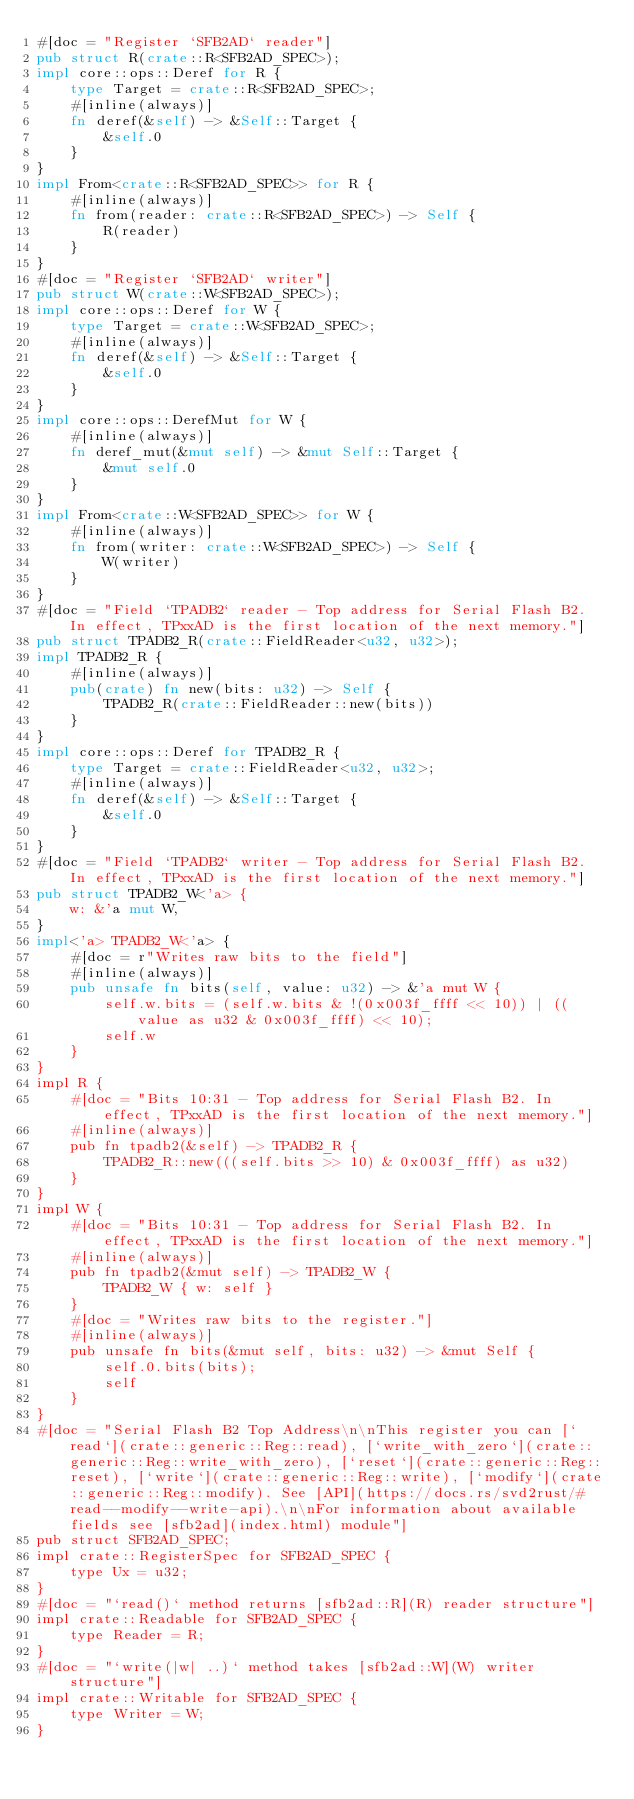<code> <loc_0><loc_0><loc_500><loc_500><_Rust_>#[doc = "Register `SFB2AD` reader"]
pub struct R(crate::R<SFB2AD_SPEC>);
impl core::ops::Deref for R {
    type Target = crate::R<SFB2AD_SPEC>;
    #[inline(always)]
    fn deref(&self) -> &Self::Target {
        &self.0
    }
}
impl From<crate::R<SFB2AD_SPEC>> for R {
    #[inline(always)]
    fn from(reader: crate::R<SFB2AD_SPEC>) -> Self {
        R(reader)
    }
}
#[doc = "Register `SFB2AD` writer"]
pub struct W(crate::W<SFB2AD_SPEC>);
impl core::ops::Deref for W {
    type Target = crate::W<SFB2AD_SPEC>;
    #[inline(always)]
    fn deref(&self) -> &Self::Target {
        &self.0
    }
}
impl core::ops::DerefMut for W {
    #[inline(always)]
    fn deref_mut(&mut self) -> &mut Self::Target {
        &mut self.0
    }
}
impl From<crate::W<SFB2AD_SPEC>> for W {
    #[inline(always)]
    fn from(writer: crate::W<SFB2AD_SPEC>) -> Self {
        W(writer)
    }
}
#[doc = "Field `TPADB2` reader - Top address for Serial Flash B2. In effect, TPxxAD is the first location of the next memory."]
pub struct TPADB2_R(crate::FieldReader<u32, u32>);
impl TPADB2_R {
    #[inline(always)]
    pub(crate) fn new(bits: u32) -> Self {
        TPADB2_R(crate::FieldReader::new(bits))
    }
}
impl core::ops::Deref for TPADB2_R {
    type Target = crate::FieldReader<u32, u32>;
    #[inline(always)]
    fn deref(&self) -> &Self::Target {
        &self.0
    }
}
#[doc = "Field `TPADB2` writer - Top address for Serial Flash B2. In effect, TPxxAD is the first location of the next memory."]
pub struct TPADB2_W<'a> {
    w: &'a mut W,
}
impl<'a> TPADB2_W<'a> {
    #[doc = r"Writes raw bits to the field"]
    #[inline(always)]
    pub unsafe fn bits(self, value: u32) -> &'a mut W {
        self.w.bits = (self.w.bits & !(0x003f_ffff << 10)) | ((value as u32 & 0x003f_ffff) << 10);
        self.w
    }
}
impl R {
    #[doc = "Bits 10:31 - Top address for Serial Flash B2. In effect, TPxxAD is the first location of the next memory."]
    #[inline(always)]
    pub fn tpadb2(&self) -> TPADB2_R {
        TPADB2_R::new(((self.bits >> 10) & 0x003f_ffff) as u32)
    }
}
impl W {
    #[doc = "Bits 10:31 - Top address for Serial Flash B2. In effect, TPxxAD is the first location of the next memory."]
    #[inline(always)]
    pub fn tpadb2(&mut self) -> TPADB2_W {
        TPADB2_W { w: self }
    }
    #[doc = "Writes raw bits to the register."]
    #[inline(always)]
    pub unsafe fn bits(&mut self, bits: u32) -> &mut Self {
        self.0.bits(bits);
        self
    }
}
#[doc = "Serial Flash B2 Top Address\n\nThis register you can [`read`](crate::generic::Reg::read), [`write_with_zero`](crate::generic::Reg::write_with_zero), [`reset`](crate::generic::Reg::reset), [`write`](crate::generic::Reg::write), [`modify`](crate::generic::Reg::modify). See [API](https://docs.rs/svd2rust/#read--modify--write-api).\n\nFor information about available fields see [sfb2ad](index.html) module"]
pub struct SFB2AD_SPEC;
impl crate::RegisterSpec for SFB2AD_SPEC {
    type Ux = u32;
}
#[doc = "`read()` method returns [sfb2ad::R](R) reader structure"]
impl crate::Readable for SFB2AD_SPEC {
    type Reader = R;
}
#[doc = "`write(|w| ..)` method takes [sfb2ad::W](W) writer structure"]
impl crate::Writable for SFB2AD_SPEC {
    type Writer = W;
}</code> 